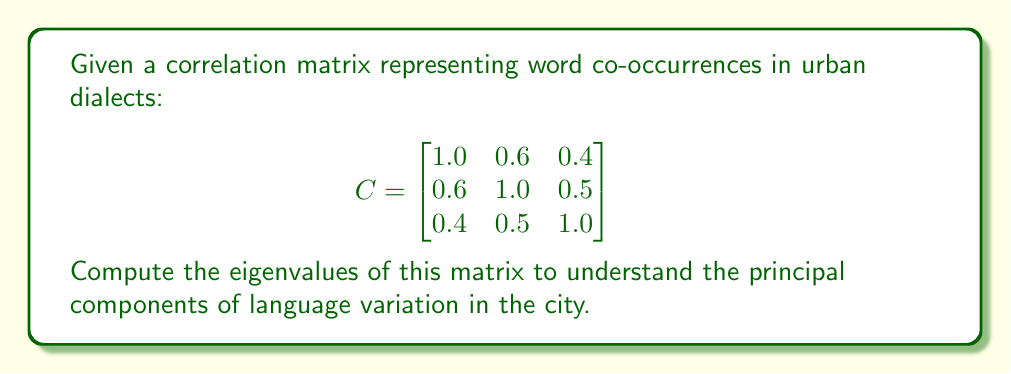Could you help me with this problem? To find the eigenvalues of the correlation matrix C, we need to solve the characteristic equation:

1. Set up the characteristic equation:
   $\det(C - \lambda I) = 0$, where $I$ is the 3x3 identity matrix.

2. Expand the determinant:
   $$\begin{vmatrix}
   1-\lambda & 0.6 & 0.4 \\
   0.6 & 1-\lambda & 0.5 \\
   0.4 & 0.5 & 1-\lambda
   \end{vmatrix} = 0$$

3. Calculate the determinant:
   $(1-\lambda)[(1-\lambda)(1-\lambda) - 0.25] - 0.6[0.6(1-\lambda) - 0.2] + 0.4[0.3 - 0.5(1-\lambda)] = 0$

4. Simplify:
   $(1-\lambda)[(1-\lambda)^2 - 0.25] - 0.36(1-\lambda) + 0.12 + 0.12 - 0.2(1-\lambda) = 0$

5. Expand:
   $(1-\lambda)^3 - 0.25(1-\lambda) - 0.36(1-\lambda) - 0.2(1-\lambda) + 0.24 = 0$

6. Combine like terms:
   $(1-\lambda)^3 - 0.81(1-\lambda) + 0.24 = 0$

7. Substitute $x = 1-\lambda$:
   $x^3 - 0.81x + 0.24 = 0$

8. Solve this cubic equation (using a computer algebra system or numerical methods):
   $x_1 \approx 1.6523$
   $x_2 \approx 0.2739$
   $x_3 \approx 0.0738$

9. Convert back to $\lambda$ values:
   $\lambda_1 = 1 - x_1 \approx -0.6523$
   $\lambda_2 = 1 - x_2 \approx 0.7261$
   $\lambda_3 = 1 - x_3 \approx 0.9262$

The eigenvalues represent the amount of variance explained by each principal component of language variation in the urban setting.
Answer: $\lambda_1 \approx -0.6523$, $\lambda_2 \approx 0.7261$, $\lambda_3 \approx 0.9262$ 